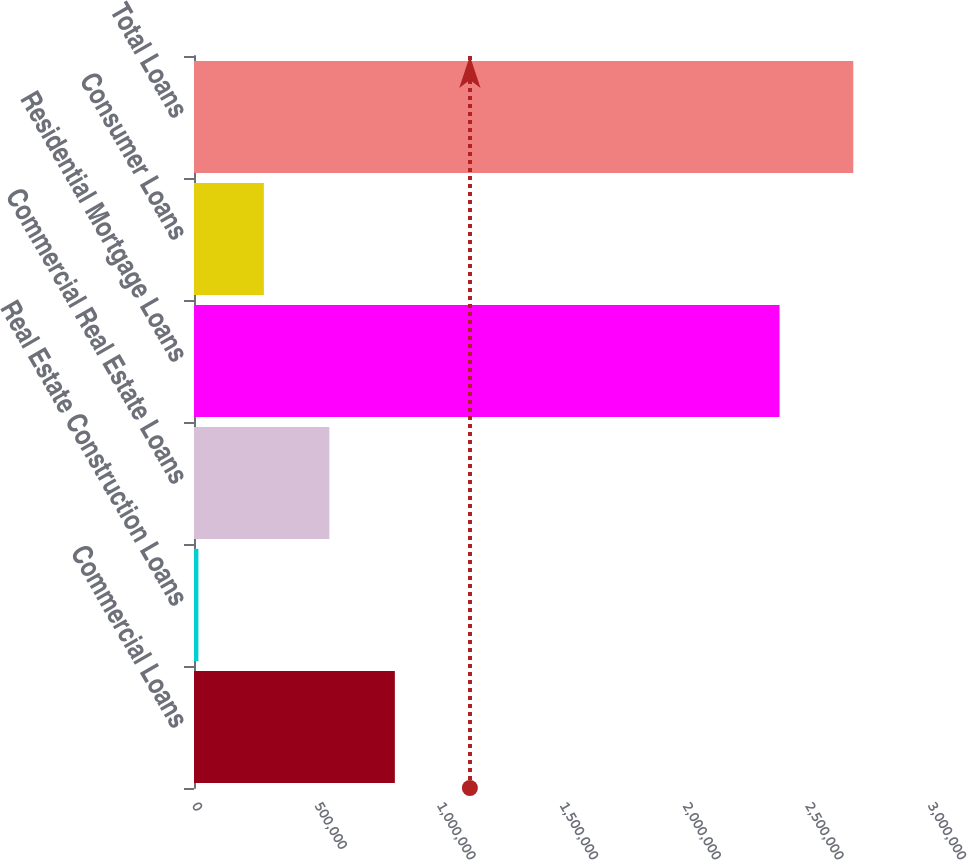<chart> <loc_0><loc_0><loc_500><loc_500><bar_chart><fcel>Commercial Loans<fcel>Real Estate Construction Loans<fcel>Commercial Real Estate Loans<fcel>Residential Mortgage Loans<fcel>Consumer Loans<fcel>Total Loans<nl><fcel>818706<fcel>17860<fcel>551758<fcel>2.38676e+06<fcel>284809<fcel>2.68735e+06<nl></chart> 